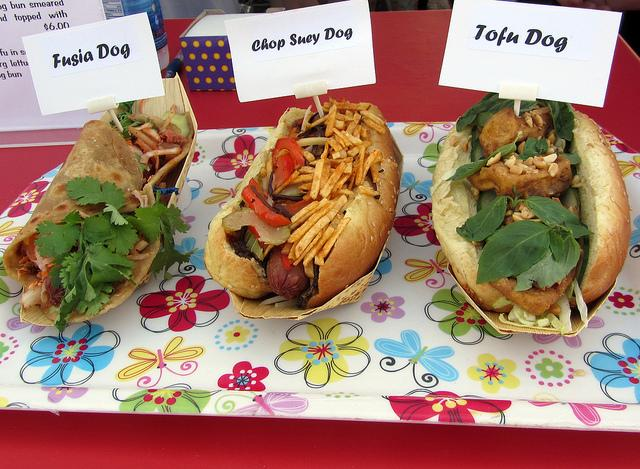What would a vegetarian order from this restaurant? Please explain your reasoning. tofu dog. The vegetarian would need to get tofu. 